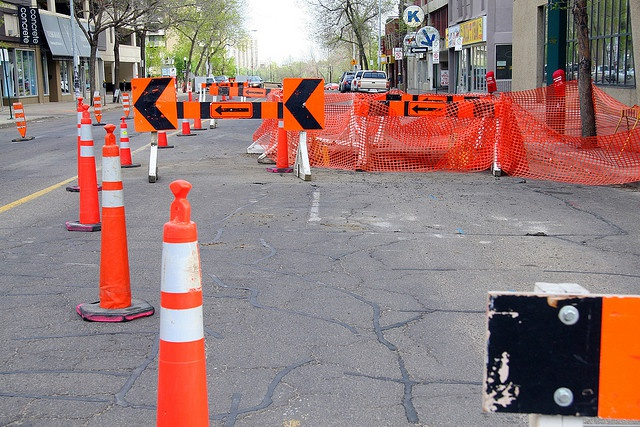Describe the objects in this image and their specific colors. I can see car in black, darkgray, lightgray, gray, and navy tones, car in black, darkgray, and gray tones, car in black, darkgray, lightgray, and gray tones, parking meter in black, maroon, brown, and darkgray tones, and car in black, lightgray, lightblue, and darkgray tones in this image. 